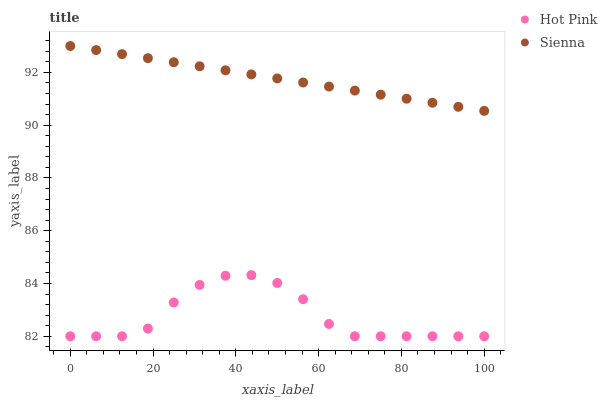Does Hot Pink have the minimum area under the curve?
Answer yes or no. Yes. Does Sienna have the maximum area under the curve?
Answer yes or no. Yes. Does Hot Pink have the maximum area under the curve?
Answer yes or no. No. Is Sienna the smoothest?
Answer yes or no. Yes. Is Hot Pink the roughest?
Answer yes or no. Yes. Is Hot Pink the smoothest?
Answer yes or no. No. Does Hot Pink have the lowest value?
Answer yes or no. Yes. Does Sienna have the highest value?
Answer yes or no. Yes. Does Hot Pink have the highest value?
Answer yes or no. No. Is Hot Pink less than Sienna?
Answer yes or no. Yes. Is Sienna greater than Hot Pink?
Answer yes or no. Yes. Does Hot Pink intersect Sienna?
Answer yes or no. No. 